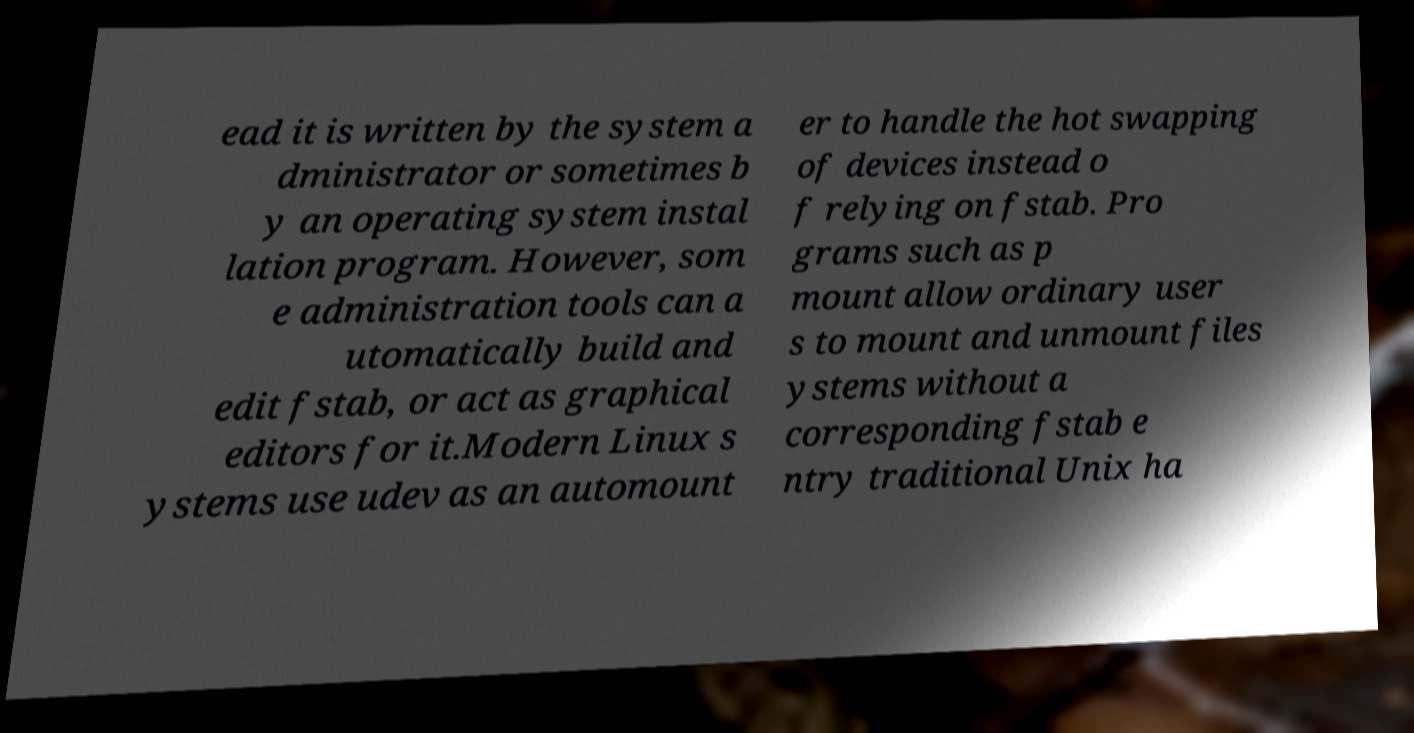Can you accurately transcribe the text from the provided image for me? ead it is written by the system a dministrator or sometimes b y an operating system instal lation program. However, som e administration tools can a utomatically build and edit fstab, or act as graphical editors for it.Modern Linux s ystems use udev as an automount er to handle the hot swapping of devices instead o f relying on fstab. Pro grams such as p mount allow ordinary user s to mount and unmount files ystems without a corresponding fstab e ntry traditional Unix ha 